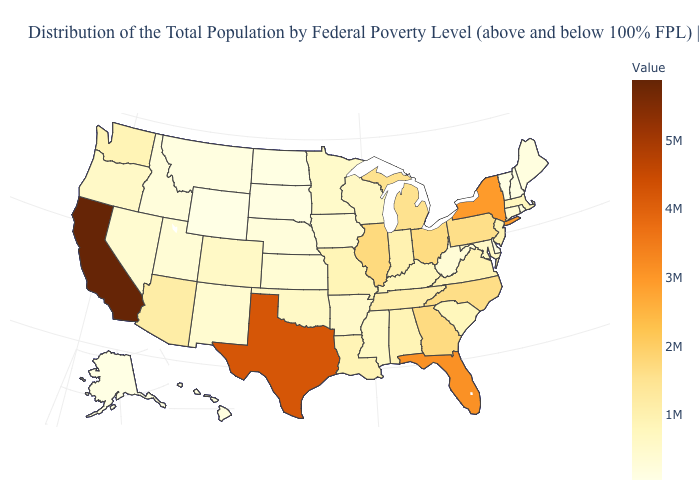Does North Carolina have the highest value in the USA?
Quick response, please. No. Among the states that border New Jersey , which have the highest value?
Write a very short answer. New York. Among the states that border South Dakota , does Nebraska have the lowest value?
Answer briefly. No. Which states hav the highest value in the South?
Concise answer only. Texas. Is the legend a continuous bar?
Short answer required. Yes. 